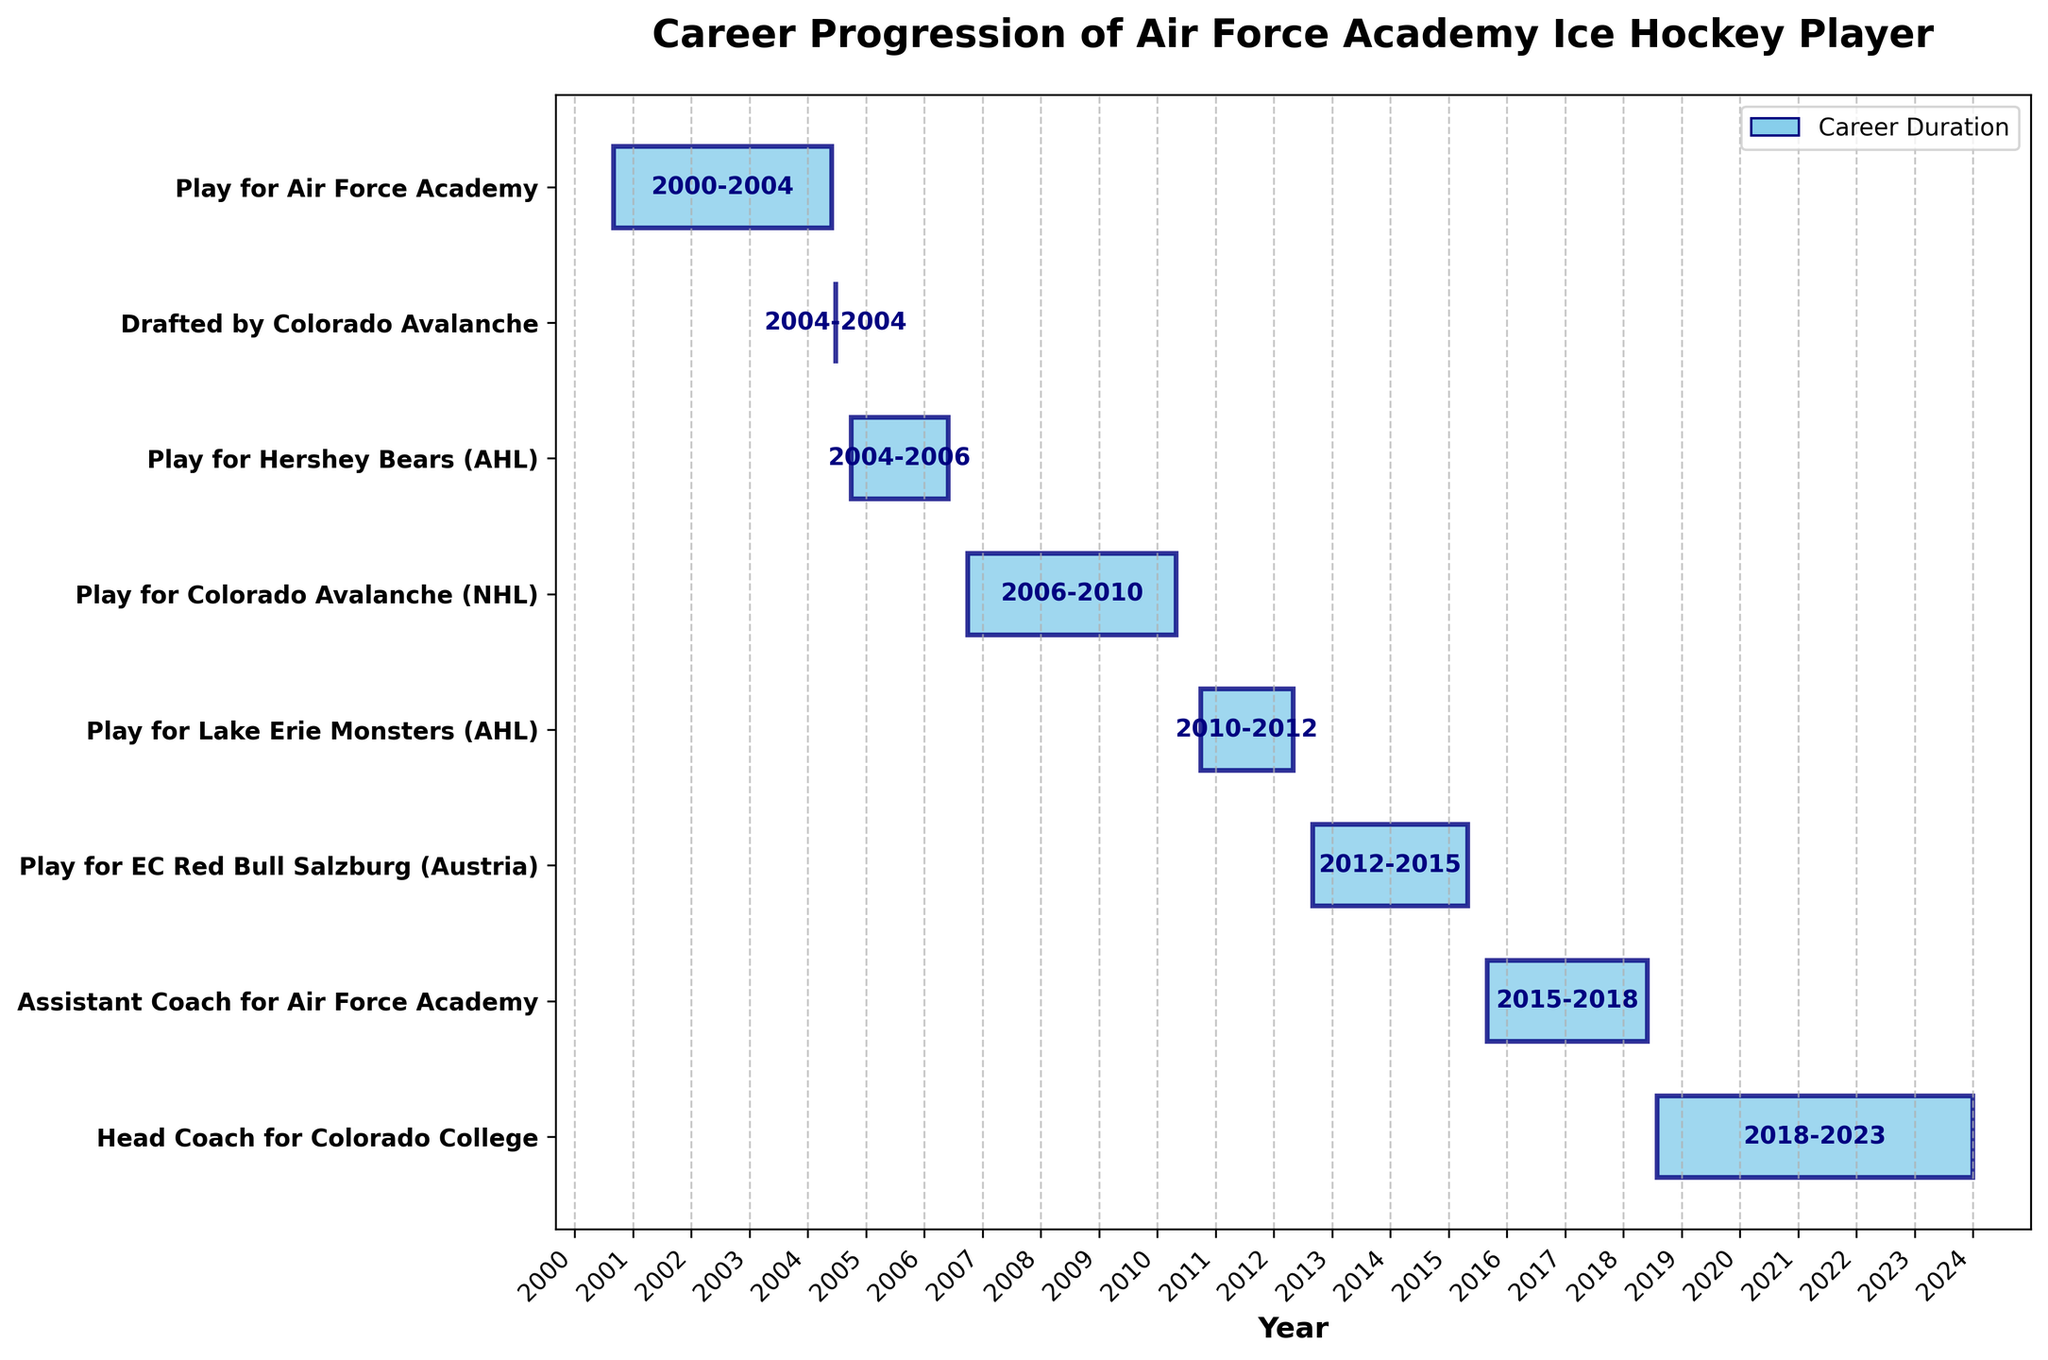What is the title of the Gantt Chart? The title can be found at the top of the chart, which states the purpose of the visualization.
Answer: Career Progression of Air Force Academy Ice Hockey Player How many years did the player play for the Colorado Avalanche (NHL)? Look at the bar labeled "Play for Colorado Avalanche (NHL)" and note the start and end years (2006-2010). Subtract the start year from the end year to determine the total duration.
Answer: 4 years Which role did the player take on after retiring from playing in Austria? Check the timeline to see the bars that follow "Play for EC Red Bull Salzburg (Austria)" and identify the next label, which is an indication of the role taken up post-Austria.
Answer: Assistant Coach for Air Force Academy How long was the player's professional career in the AHL? Identify the periods labeled with AHL involvement ("Play for Hershey Bears (AHL)" and "Play for Lake Erie Monsters (AHL)"). Calculate the durations for each period and sum them up: Hershey Bears (2004-2006) and Lake Erie Monsters (2010-2012). Calculate the total duration.
Answer: 4 years Which coaching role has the player held for a longer period, Assistant Coach for Air Force Academy or Head Coach for Colorado College? Compare the durations of the two coaching roles by subtracting the start and end years for each: Assistant Coach (2015-2018) and Head Coach (2018-2023).
Answer: Head Coach for Colorado College When was the player drafted by the Colorado Avalanche? Locate the specific event labeled "Drafted by Colorado Avalanche" and note the exact date listed on the timeline.
Answer: June 26, 2004 How many stages of the player's career, including both playing and coaching, are represented in the chart? Count all the unique labels (tasks) listed on the y-axis that denote different stages or roles in the player’s career.
Answer: 8 stages What is the approximate duration of the player's entire career, from college to the expected end of coaching at Colorado College? Identify the start of the first period ("Play for Air Force Academy" in 2000) and the end of the last period ("Head Coach for Colorado College" in 2023). Calculate the difference in years.
Answer: 23 years 